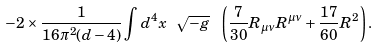<formula> <loc_0><loc_0><loc_500><loc_500>- 2 \times \frac { 1 } { 1 6 \pi ^ { 2 } ( d - 4 ) } \int d ^ { 4 } x \ \sqrt { - g } \ \left ( \frac { 7 } { 3 0 } R _ { \mu \nu } R ^ { \mu \nu } + \frac { 1 7 } { 6 0 } R ^ { 2 } \right ) .</formula> 